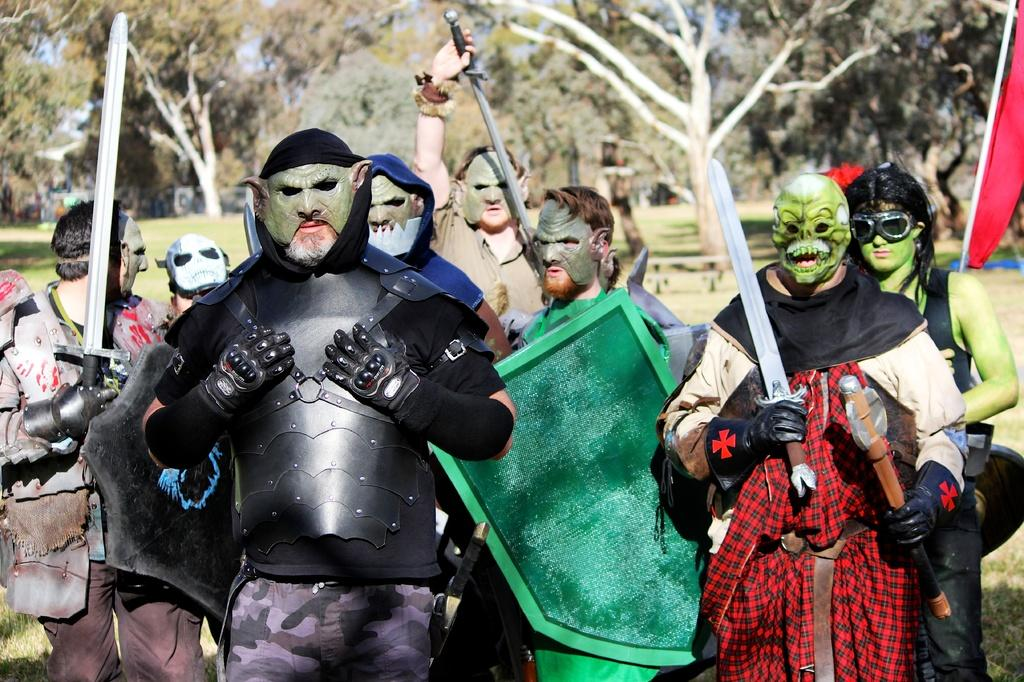What type of setting is depicted in the image? The image is an outside view. What are the people in the image wearing? The people are wearing costumes in the image. What can be seen on the faces of the people in the image? The people have masks on their faces. What objects are the people holding in the image? The people are holding swords in their hands. What type of natural environment is visible in the background of the image? There are trees visible in the background of the image. What is the shortest distance between the people and the airplane in the image? There is no airplane present in the image, so it is not possible to determine the distance between the people and an airplane. 